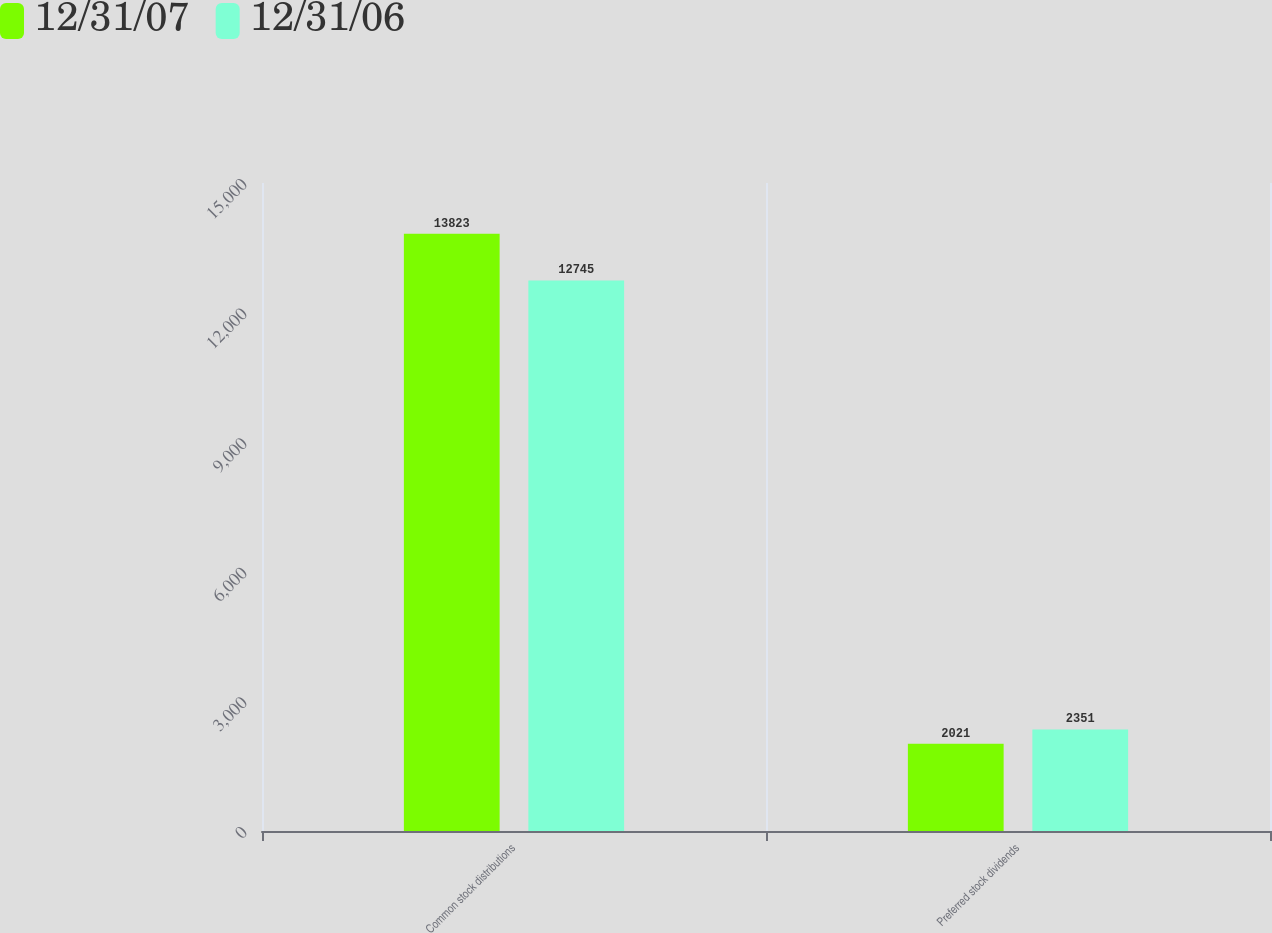Convert chart to OTSL. <chart><loc_0><loc_0><loc_500><loc_500><stacked_bar_chart><ecel><fcel>Common stock distributions<fcel>Preferred stock dividends<nl><fcel>12/31/07<fcel>13823<fcel>2021<nl><fcel>12/31/06<fcel>12745<fcel>2351<nl></chart> 